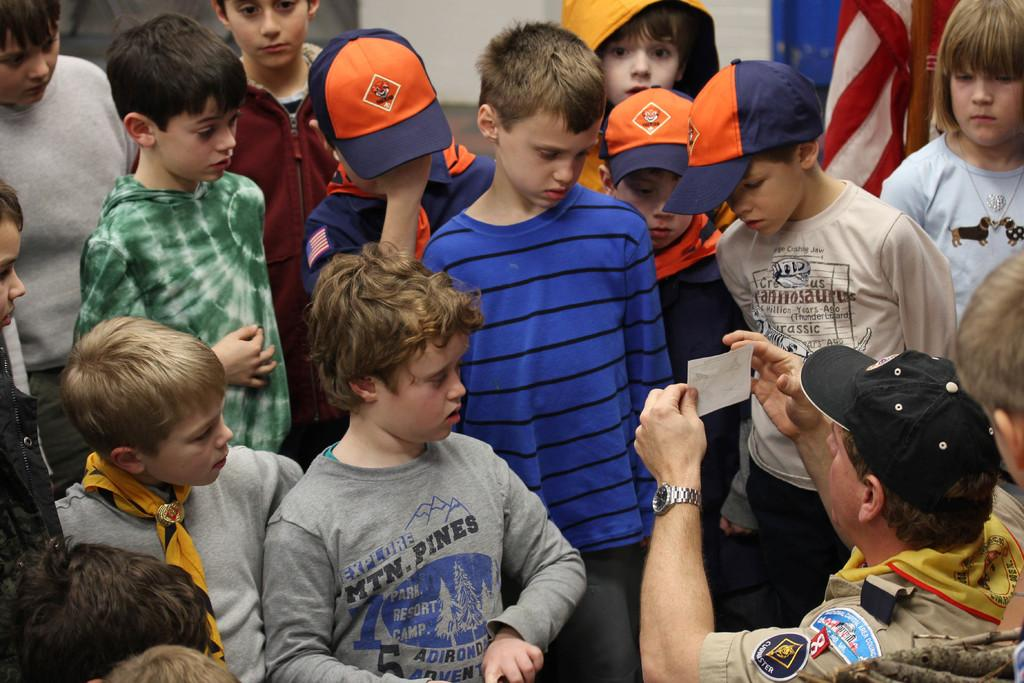Who is present in the image? There are people in the image. What is the man holding in the image? The man is holding a paper with his hands. What can be seen in the background of the image? There is a flag and a wall in the background of the image. What type of reward is the man receiving in the image? There is no indication in the image that the man is receiving a reward, so it cannot be determined from the picture. 